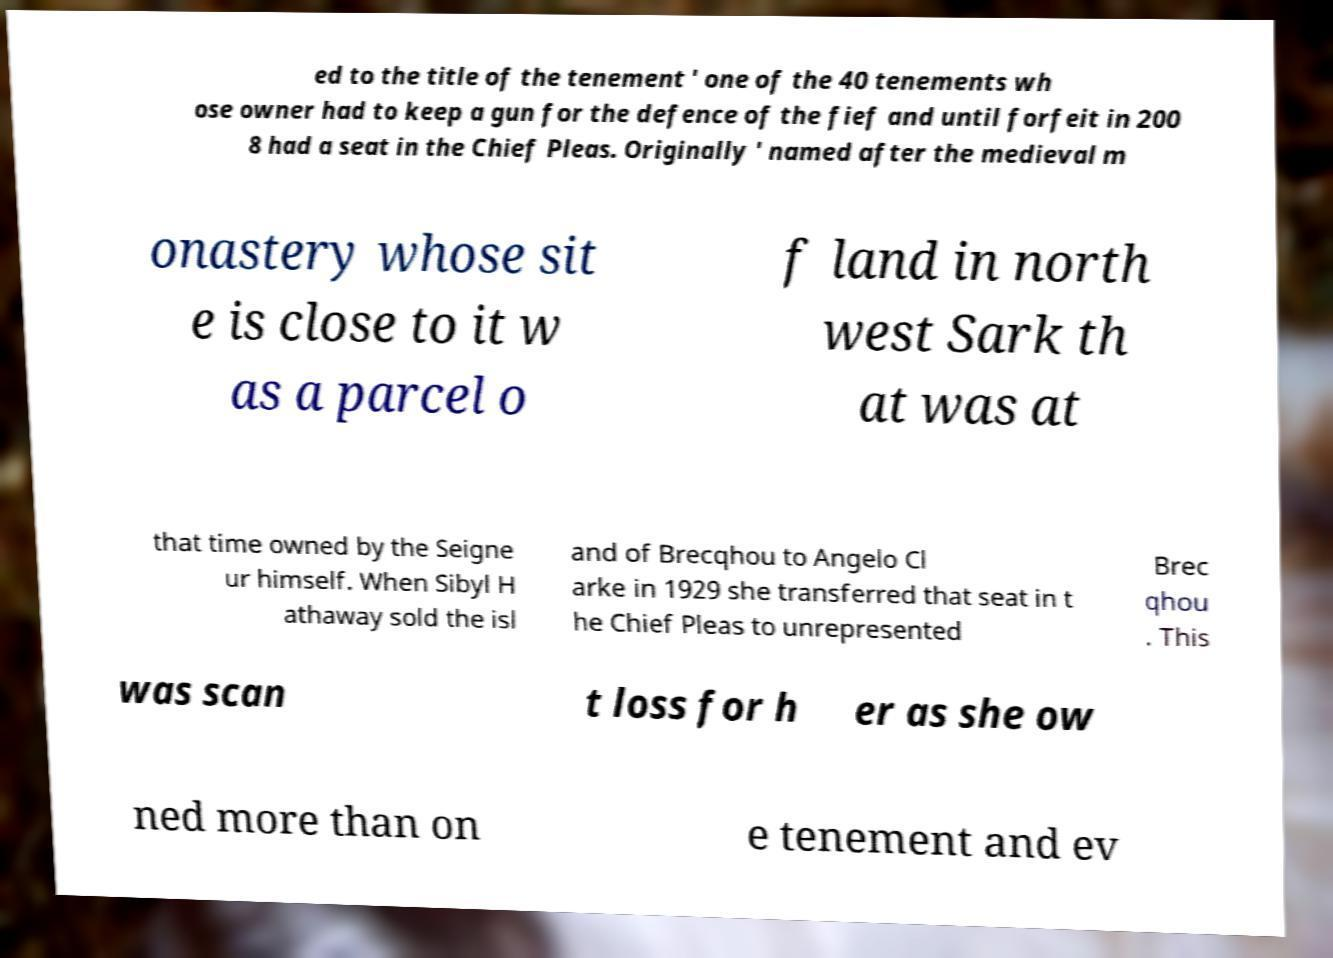What messages or text are displayed in this image? I need them in a readable, typed format. ed to the title of the tenement ' one of the 40 tenements wh ose owner had to keep a gun for the defence of the fief and until forfeit in 200 8 had a seat in the Chief Pleas. Originally ' named after the medieval m onastery whose sit e is close to it w as a parcel o f land in north west Sark th at was at that time owned by the Seigne ur himself. When Sibyl H athaway sold the isl and of Brecqhou to Angelo Cl arke in 1929 she transferred that seat in t he Chief Pleas to unrepresented Brec qhou . This was scan t loss for h er as she ow ned more than on e tenement and ev 